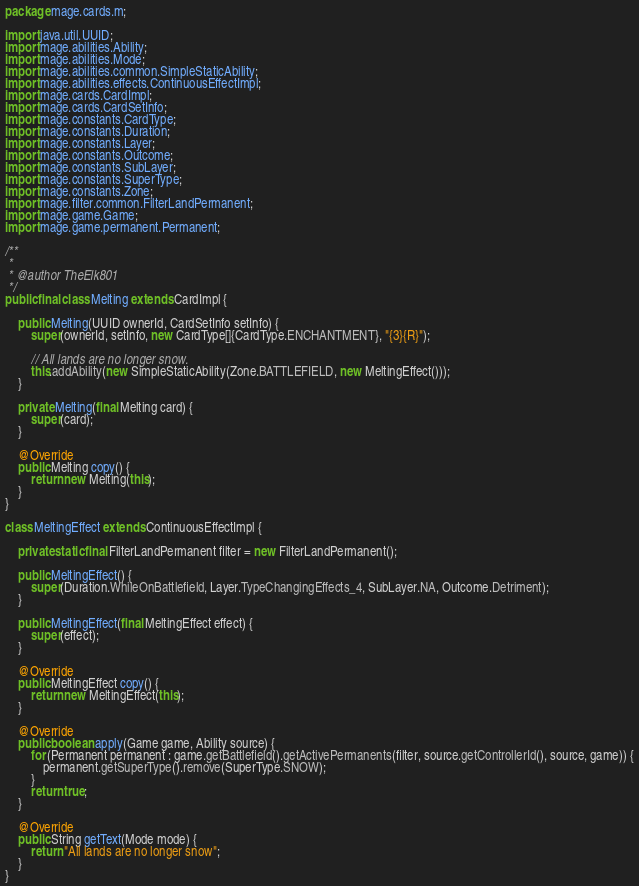Convert code to text. <code><loc_0><loc_0><loc_500><loc_500><_Java_>
package mage.cards.m;

import java.util.UUID;
import mage.abilities.Ability;
import mage.abilities.Mode;
import mage.abilities.common.SimpleStaticAbility;
import mage.abilities.effects.ContinuousEffectImpl;
import mage.cards.CardImpl;
import mage.cards.CardSetInfo;
import mage.constants.CardType;
import mage.constants.Duration;
import mage.constants.Layer;
import mage.constants.Outcome;
import mage.constants.SubLayer;
import mage.constants.SuperType;
import mage.constants.Zone;
import mage.filter.common.FilterLandPermanent;
import mage.game.Game;
import mage.game.permanent.Permanent;

/**
 *
 * @author TheElk801
 */
public final class Melting extends CardImpl {

    public Melting(UUID ownerId, CardSetInfo setInfo) {
        super(ownerId, setInfo, new CardType[]{CardType.ENCHANTMENT}, "{3}{R}");

        // All lands are no longer snow.
        this.addAbility(new SimpleStaticAbility(Zone.BATTLEFIELD, new MeltingEffect()));
    }

    private Melting(final Melting card) {
        super(card);
    }

    @Override
    public Melting copy() {
        return new Melting(this);
    }
}

class MeltingEffect extends ContinuousEffectImpl {

    private static final FilterLandPermanent filter = new FilterLandPermanent();

    public MeltingEffect() {
        super(Duration.WhileOnBattlefield, Layer.TypeChangingEffects_4, SubLayer.NA, Outcome.Detriment);
    }

    public MeltingEffect(final MeltingEffect effect) {
        super(effect);
    }

    @Override
    public MeltingEffect copy() {
        return new MeltingEffect(this);
    }

    @Override
    public boolean apply(Game game, Ability source) {
        for (Permanent permanent : game.getBattlefield().getActivePermanents(filter, source.getControllerId(), source, game)) {
            permanent.getSuperType().remove(SuperType.SNOW);
        }
        return true;
    }

    @Override
    public String getText(Mode mode) {
        return "All lands are no longer snow";
    }
}
</code> 